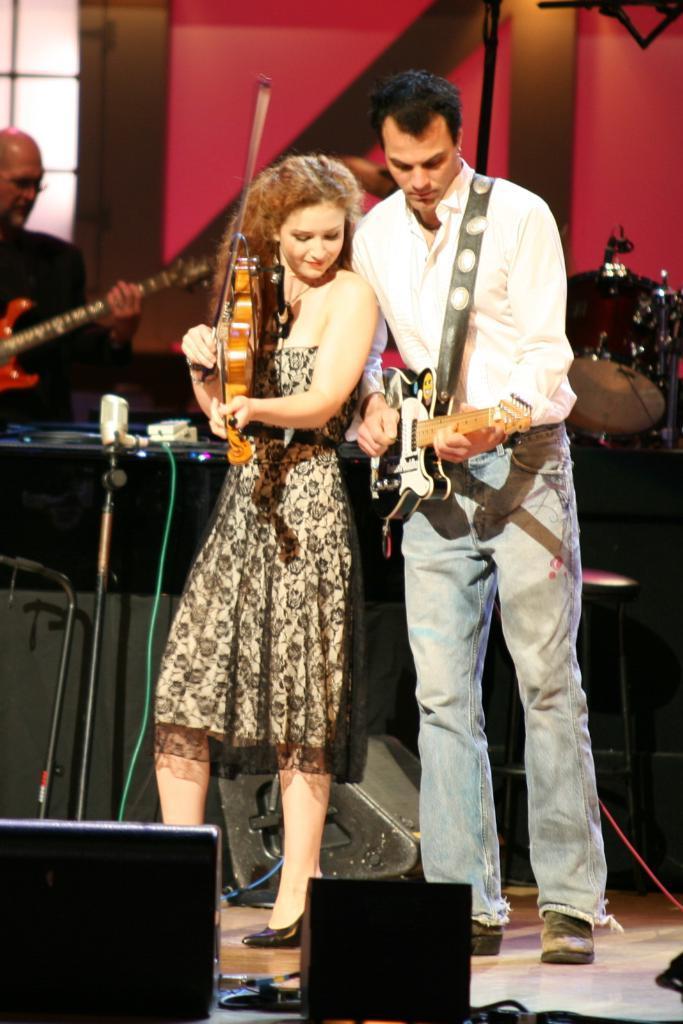Could you give a brief overview of what you see in this image? The person wearing white shirt is playing guitar and the lady beside him is playing violin and there are group of people behind them is playing guitar and there are also drums in the background. 